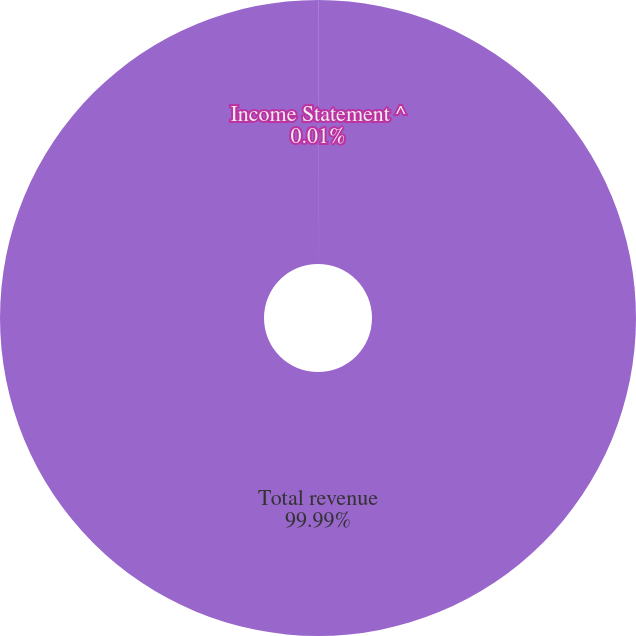Convert chart. <chart><loc_0><loc_0><loc_500><loc_500><pie_chart><fcel>Income Statement ^<fcel>Total revenue<nl><fcel>0.01%<fcel>99.99%<nl></chart> 